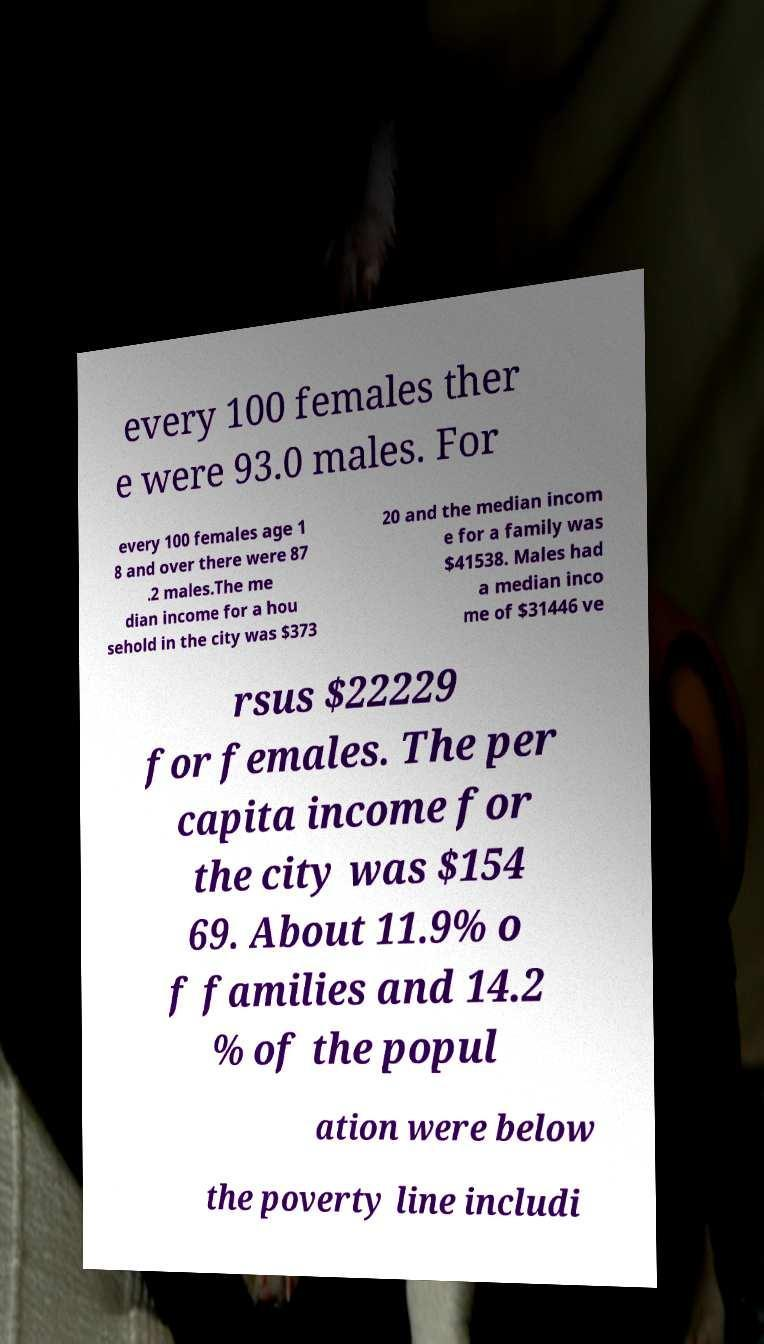Please identify and transcribe the text found in this image. every 100 females ther e were 93.0 males. For every 100 females age 1 8 and over there were 87 .2 males.The me dian income for a hou sehold in the city was $373 20 and the median incom e for a family was $41538. Males had a median inco me of $31446 ve rsus $22229 for females. The per capita income for the city was $154 69. About 11.9% o f families and 14.2 % of the popul ation were below the poverty line includi 